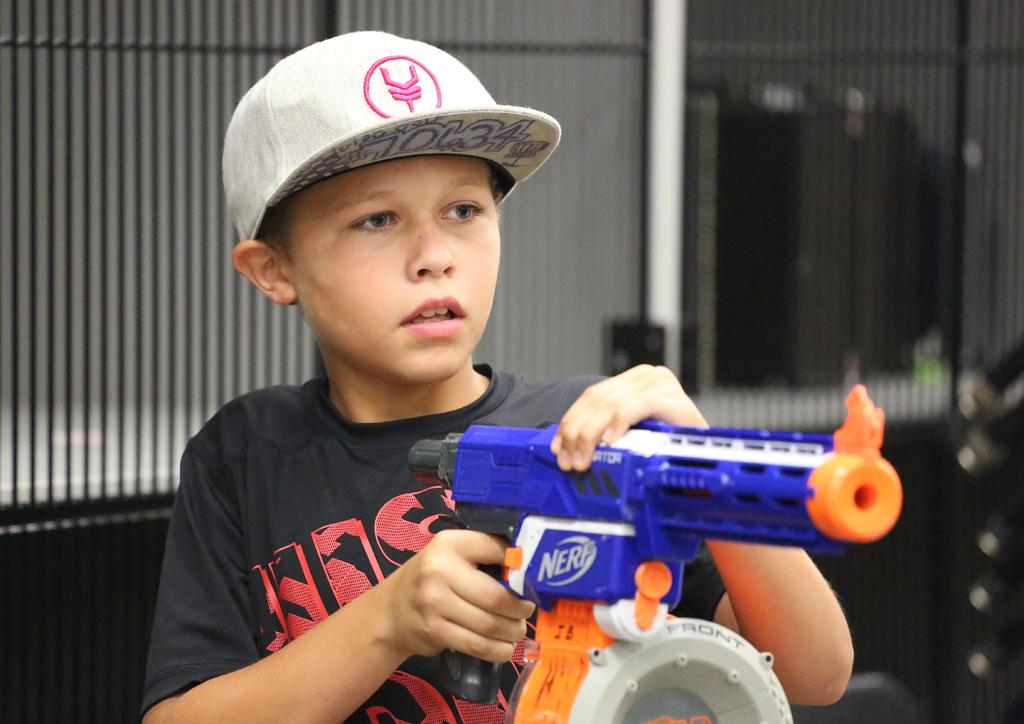Who is present in the image? There is a boy in the image. What is the boy holding in the image? The boy is holding a gun. What type of headwear is the boy wearing? The boy is wearing a cap. What can be seen in the background of the image? There is a fence in the background of the image. Can you see any mountains in the image? There are no mountains present in the image. 